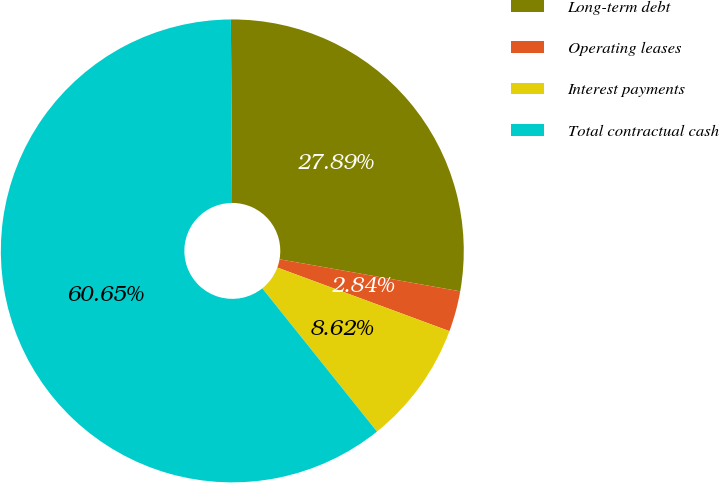<chart> <loc_0><loc_0><loc_500><loc_500><pie_chart><fcel>Long-term debt<fcel>Operating leases<fcel>Interest payments<fcel>Total contractual cash<nl><fcel>27.89%<fcel>2.84%<fcel>8.62%<fcel>60.64%<nl></chart> 